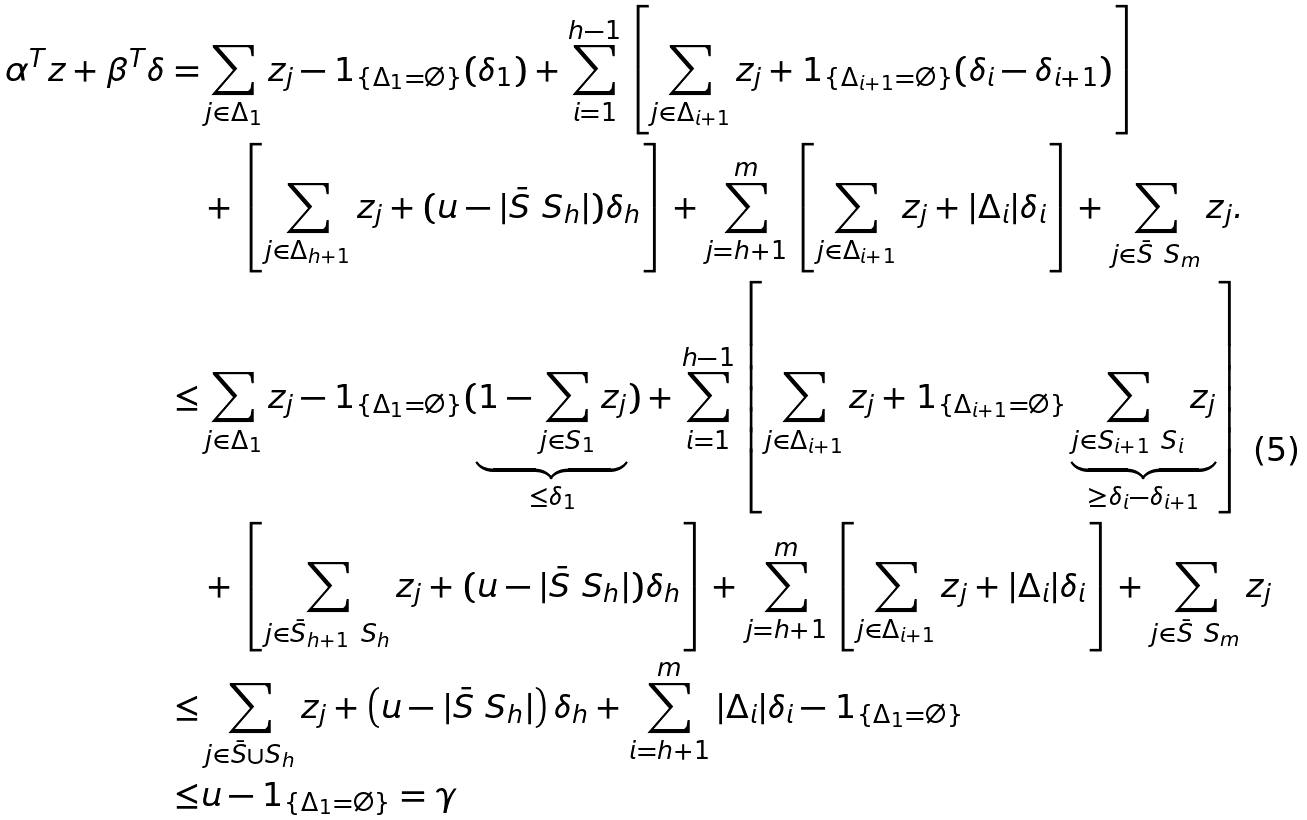Convert formula to latex. <formula><loc_0><loc_0><loc_500><loc_500>\alpha ^ { T } z + \beta ^ { T } \delta = & \sum _ { j \in \Delta _ { 1 } } z _ { j } - \mathbb { m } { 1 } _ { \{ \Delta _ { 1 } = \emptyset \} } ( \delta _ { 1 } ) + \sum _ { i = 1 } ^ { h - 1 } \left [ \sum _ { j \in \Delta _ { i + 1 } } z _ { j } + \mathbb { m } { 1 } _ { \{ \Delta _ { i + 1 } = \emptyset \} } ( \delta _ { i } - \delta _ { i + 1 } ) \right ] \\ & + \left [ \sum _ { j \in \Delta _ { h + 1 } } z _ { j } + ( u - | \bar { S } \ S _ { h } | ) \delta _ { h } \right ] + \sum _ { j = h + 1 } ^ { m } \left [ \sum _ { j \in \Delta _ { i + 1 } } z _ { j } + | \Delta _ { i } | \delta _ { i } \right ] + \sum _ { j \in \bar { S } \ S _ { m } } z _ { j } . \\ \leq & \sum _ { j \in \Delta _ { 1 } } z _ { j } - \mathbb { m } { 1 } _ { \{ \Delta _ { 1 } = \emptyset \} } ( \underbrace { 1 - \sum _ { j \in S _ { 1 } } z _ { j } } _ { \leq \delta _ { 1 } } ) + \sum _ { i = 1 } ^ { h - 1 } \left [ \sum _ { j \in \Delta _ { i + 1 } } z _ { j } + \mathbb { m } { 1 } _ { \{ \Delta _ { i + 1 } = \emptyset \} } \underbrace { \sum _ { j \in S _ { i + 1 } \ S _ { i } } z _ { j } } _ { \geq \delta _ { i } - \delta _ { i + 1 } } \right ] \\ & + \left [ \sum _ { j \in \bar { S } _ { h + 1 } \ S _ { h } } z _ { j } + ( u - | \bar { S } \ S _ { h } | ) \delta _ { h } \right ] + \sum _ { j = h + 1 } ^ { m } \left [ \sum _ { j \in \Delta _ { i + 1 } } z _ { j } + | \Delta _ { i } | \delta _ { i } \right ] + \sum _ { j \in \bar { S } \ S _ { m } } z _ { j } \\ \leq & \sum _ { j \in \bar { S } \cup S _ { h } } z _ { j } + \left ( u - | \bar { S } \ S _ { h } | \right ) \delta _ { h } + \sum _ { i = h + 1 } ^ { m } | \Delta _ { i } | \delta _ { i } - \mathbb { m } { 1 } _ { \{ \Delta _ { 1 } = \emptyset \} } \\ \leq & u - \mathbb { m } { 1 } _ { \{ \Delta _ { 1 } = \emptyset \} } = \gamma</formula> 